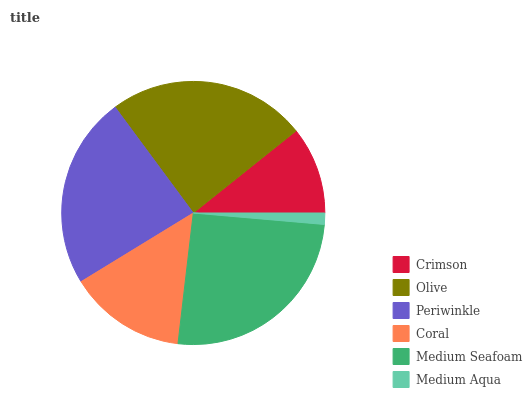Is Medium Aqua the minimum?
Answer yes or no. Yes. Is Medium Seafoam the maximum?
Answer yes or no. Yes. Is Olive the minimum?
Answer yes or no. No. Is Olive the maximum?
Answer yes or no. No. Is Olive greater than Crimson?
Answer yes or no. Yes. Is Crimson less than Olive?
Answer yes or no. Yes. Is Crimson greater than Olive?
Answer yes or no. No. Is Olive less than Crimson?
Answer yes or no. No. Is Periwinkle the high median?
Answer yes or no. Yes. Is Coral the low median?
Answer yes or no. Yes. Is Coral the high median?
Answer yes or no. No. Is Medium Aqua the low median?
Answer yes or no. No. 